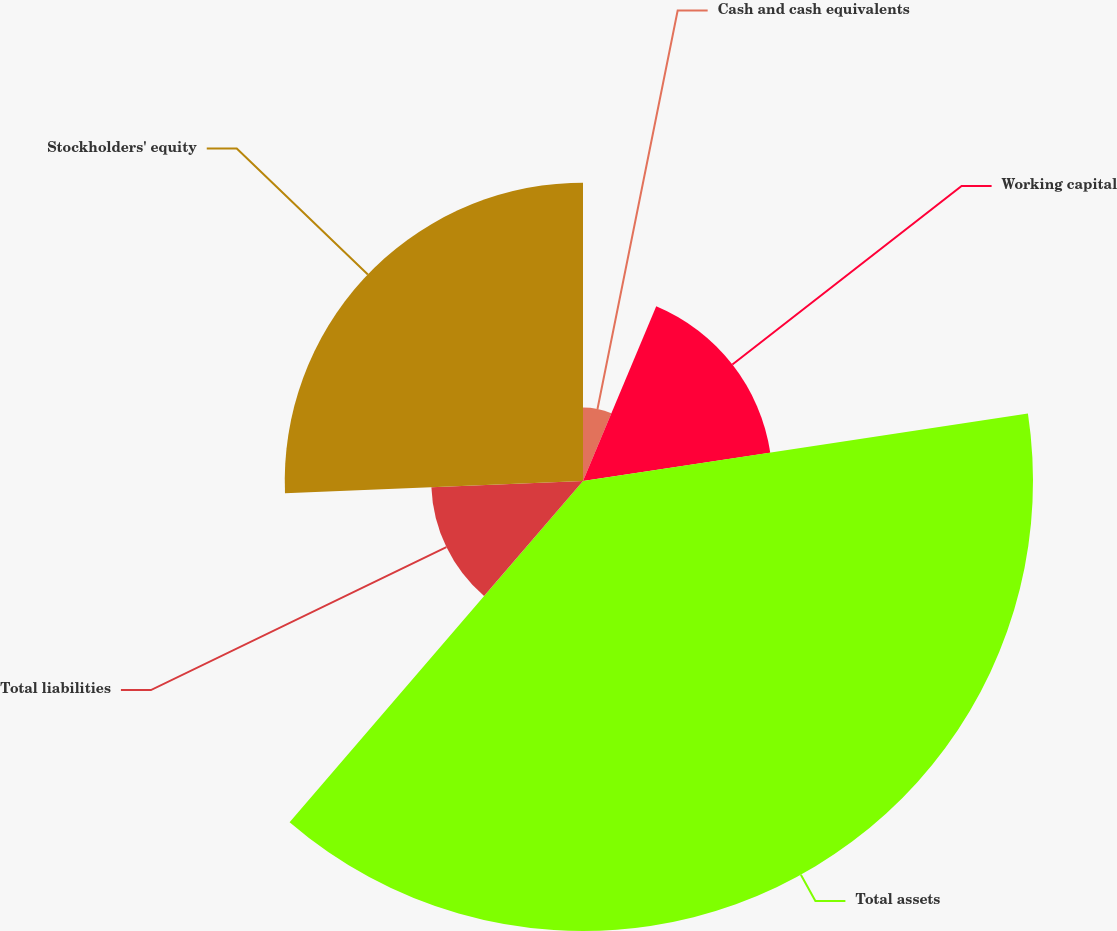<chart> <loc_0><loc_0><loc_500><loc_500><pie_chart><fcel>Cash and cash equivalents<fcel>Working capital<fcel>Total assets<fcel>Total liabilities<fcel>Stockholders' equity<nl><fcel>6.32%<fcel>16.29%<fcel>38.7%<fcel>13.05%<fcel>25.65%<nl></chart> 